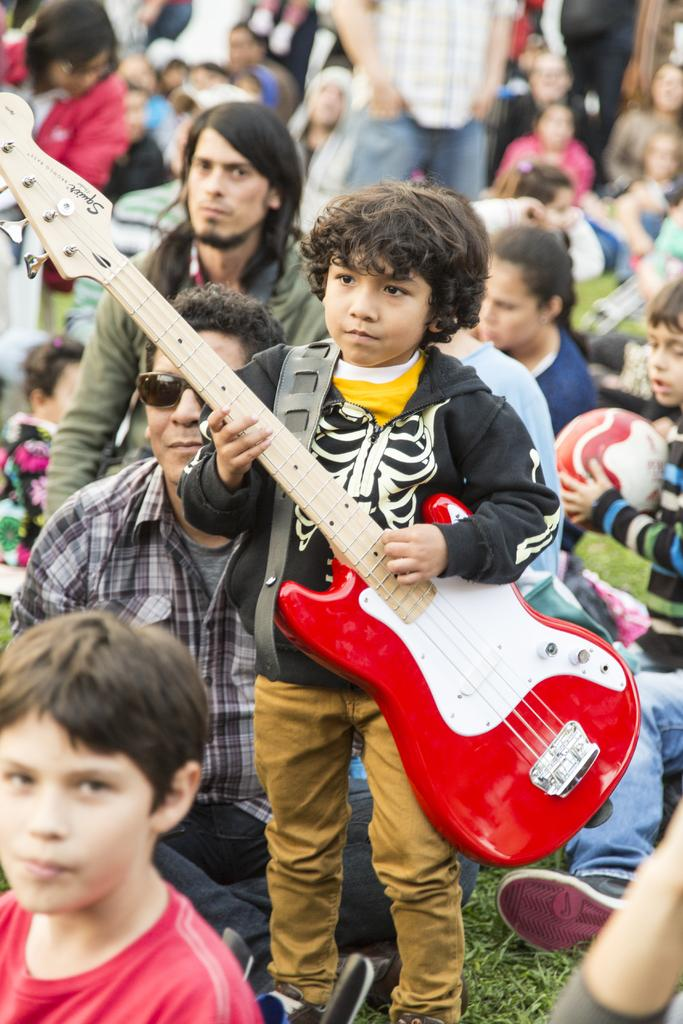What is the main subject of the image? The main subject of the image is a boy standing in the middle. What is the boy holding in the image? The boy is holding a red-colored music instrument. Can you describe the people in the background of the image? There are people sitting in the background of the image. What type of pancake is the boy eating in the image? There is no pancake present in the image; the boy is holding a red-colored music instrument. What kind of horn can be seen on the boy's shirt in the image? There is no horn visible on the boy's shirt in the image. 